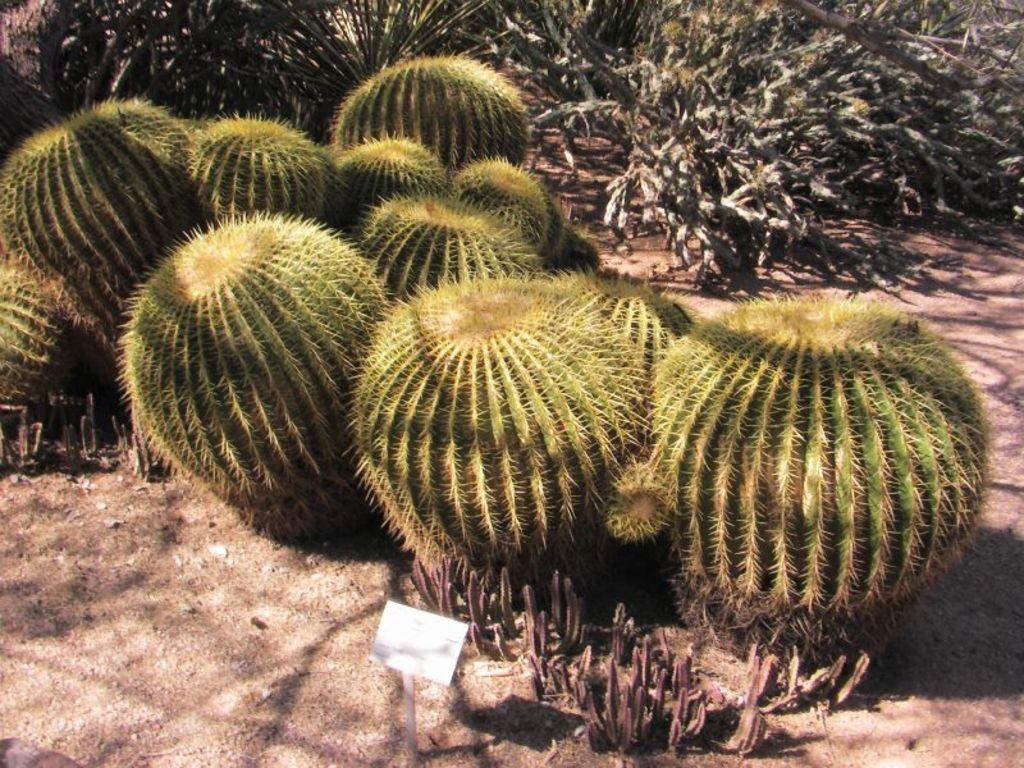Can you describe this image briefly? In this image we can see different types of plants on the ground and a name board. 